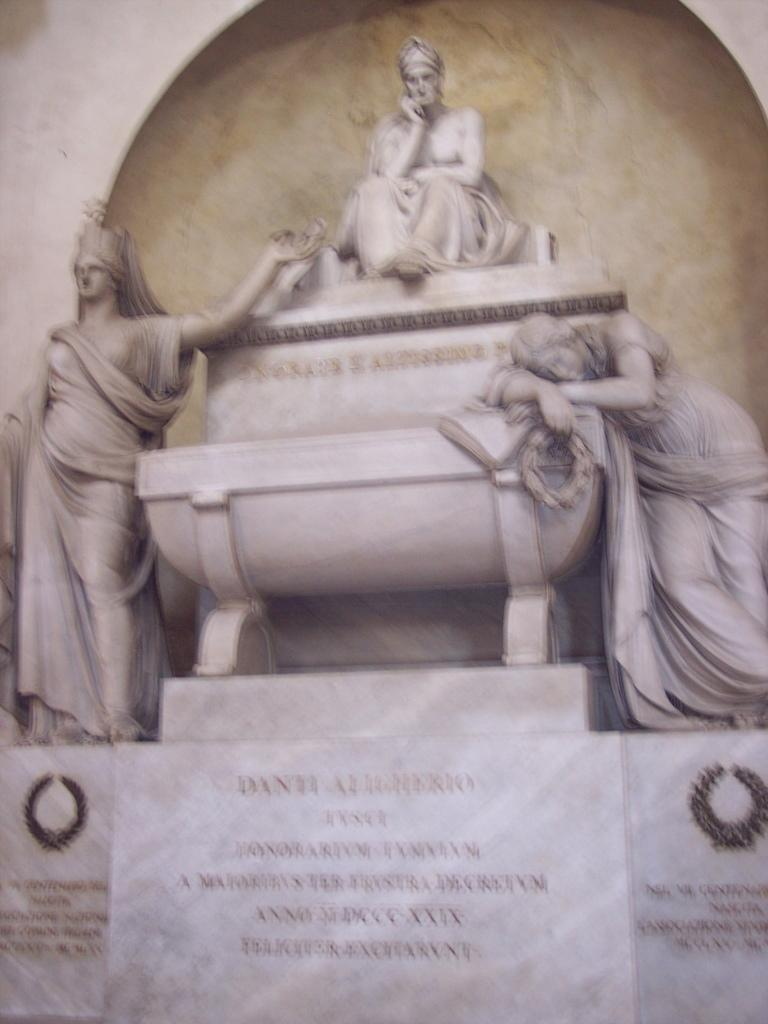What type of objects can be seen in the image? There are statues in the image. Can you describe any other features in the image? There is text on a wall in the image. What type of beast can be seen in the image? There is no beast present in the image; it features statues and text on a wall. Is there a house visible in the image? There is no house present in the image; it only contains statues and text on a wall. 